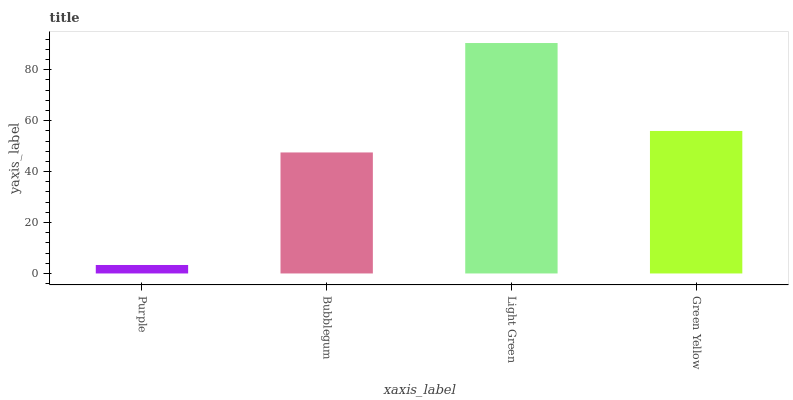Is Purple the minimum?
Answer yes or no. Yes. Is Light Green the maximum?
Answer yes or no. Yes. Is Bubblegum the minimum?
Answer yes or no. No. Is Bubblegum the maximum?
Answer yes or no. No. Is Bubblegum greater than Purple?
Answer yes or no. Yes. Is Purple less than Bubblegum?
Answer yes or no. Yes. Is Purple greater than Bubblegum?
Answer yes or no. No. Is Bubblegum less than Purple?
Answer yes or no. No. Is Green Yellow the high median?
Answer yes or no. Yes. Is Bubblegum the low median?
Answer yes or no. Yes. Is Bubblegum the high median?
Answer yes or no. No. Is Green Yellow the low median?
Answer yes or no. No. 